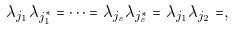<formula> <loc_0><loc_0><loc_500><loc_500>\lambda _ { j _ { 1 } } \lambda _ { j _ { 1 } ^ { * } } = \dots = \lambda _ { j _ { s } } \lambda _ { j _ { s } ^ { * } } = \lambda _ { j _ { 1 } } \lambda _ { j _ { 2 } } = ,</formula> 